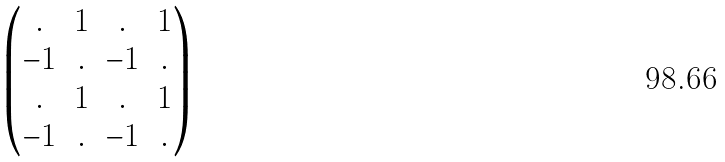<formula> <loc_0><loc_0><loc_500><loc_500>\begin{pmatrix} . & 1 & . & 1 \\ - 1 & . & - 1 & . \\ . & 1 & . & 1 \\ - 1 & . & - 1 & . \end{pmatrix}</formula> 